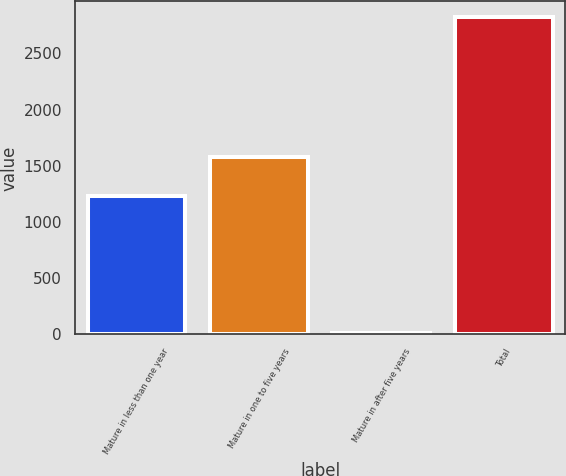Convert chart to OTSL. <chart><loc_0><loc_0><loc_500><loc_500><bar_chart><fcel>Mature in less than one year<fcel>Mature in one to five years<fcel>Mature in after five years<fcel>Total<nl><fcel>1233.5<fcel>1580.3<fcel>8<fcel>2821.8<nl></chart> 